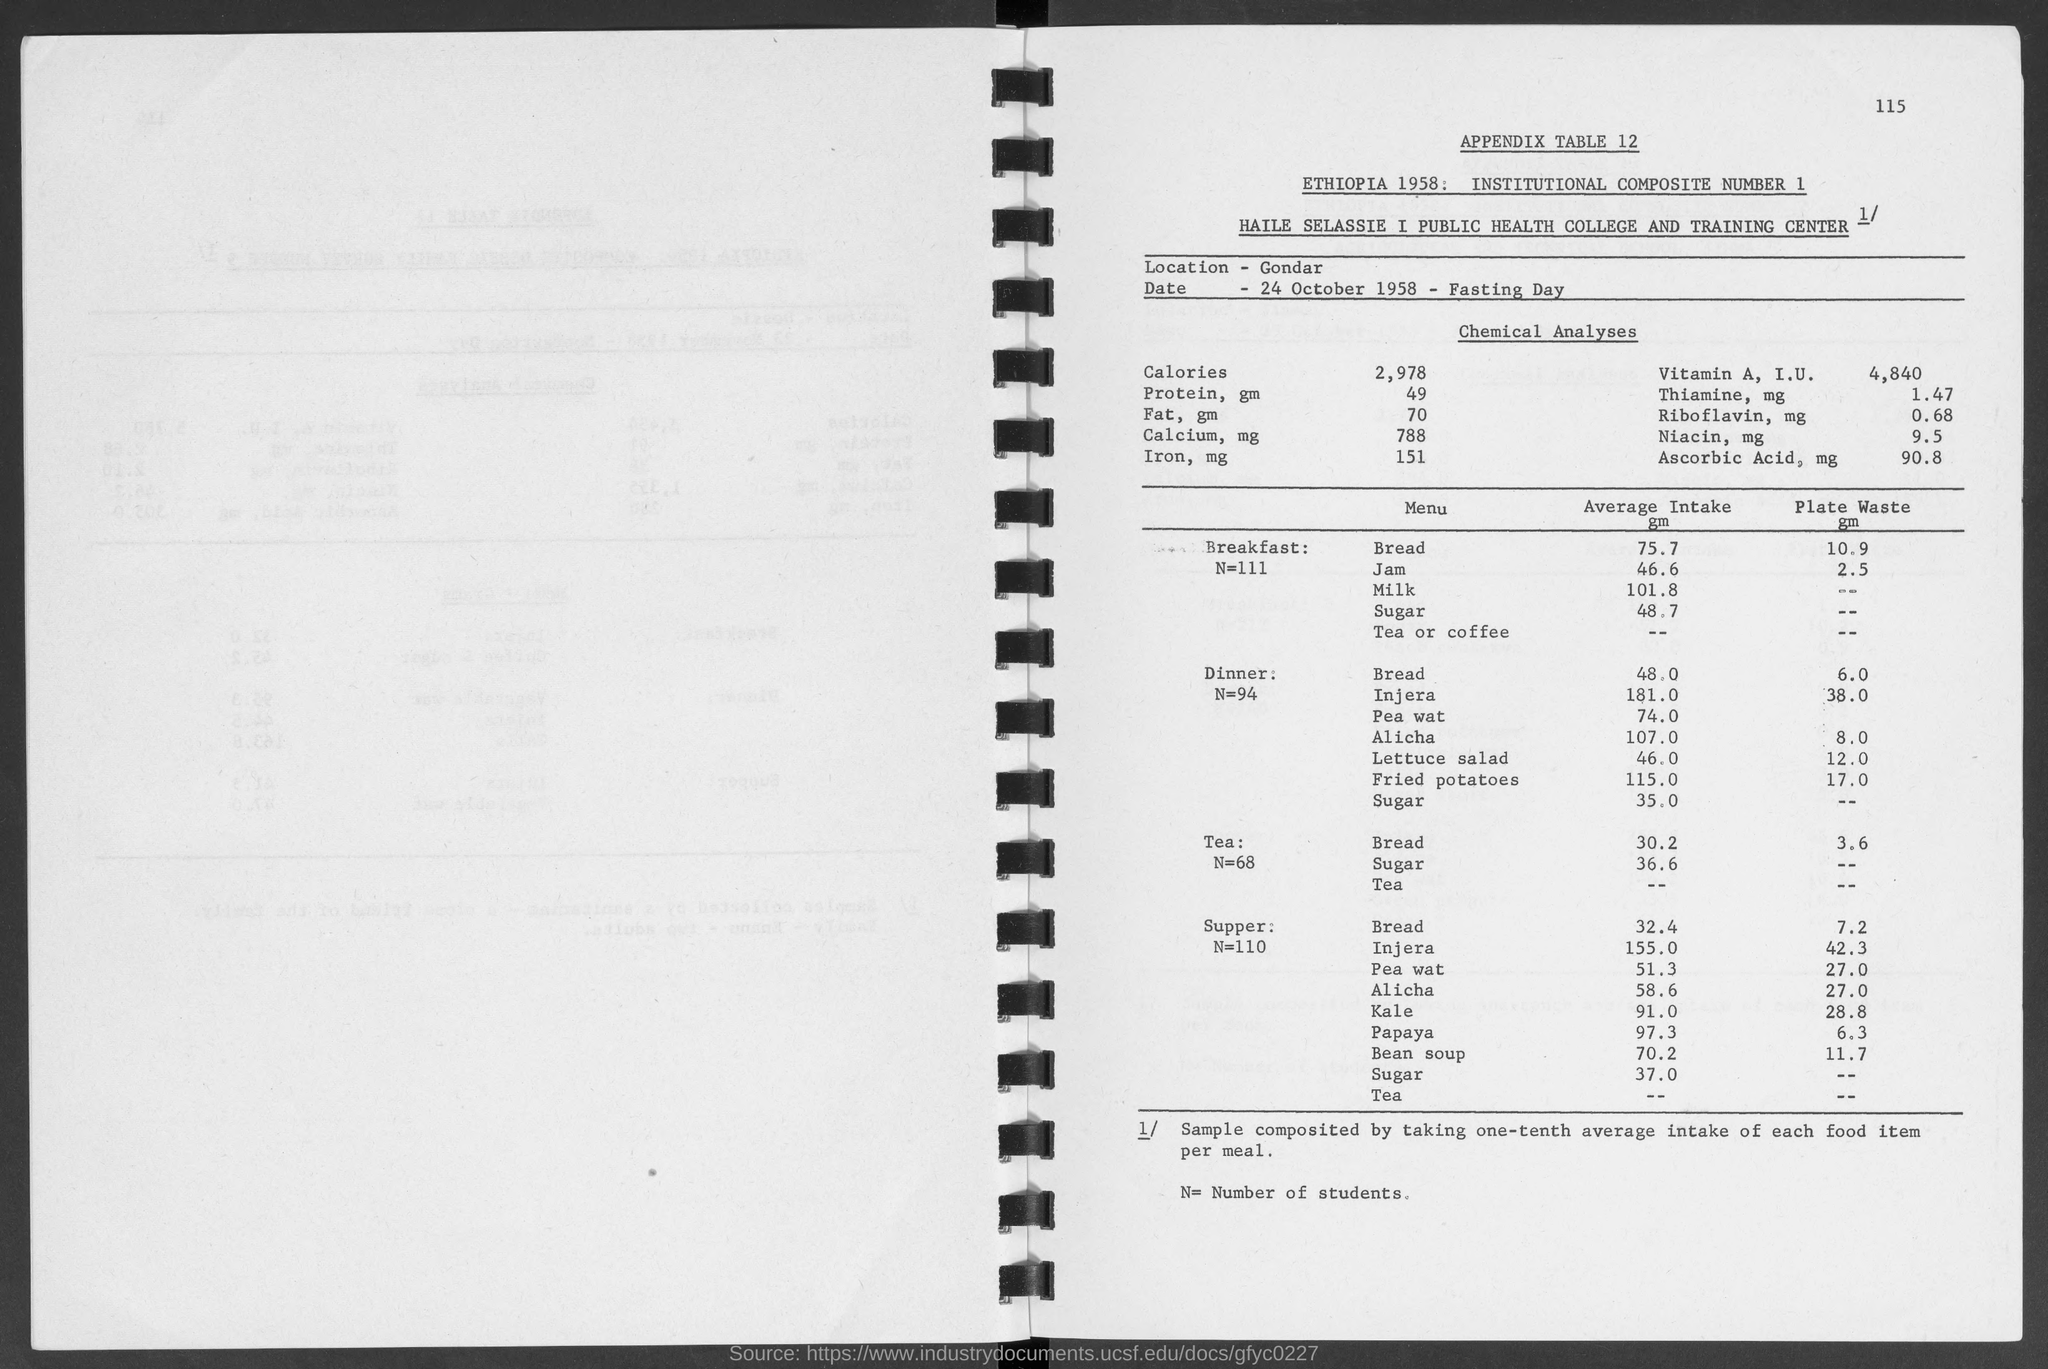Indicate a few pertinent items in this graphic. The number in the top-right corner of the page is 115. The average intake of sugar in dinner is approximately 35 grams. The average intake of bread in dinner is approximately 48.0 grams. On October 24, 1958, it was a fasting day at the specified location. On average, people consume 75.7 grams of bread in their breakfast. 